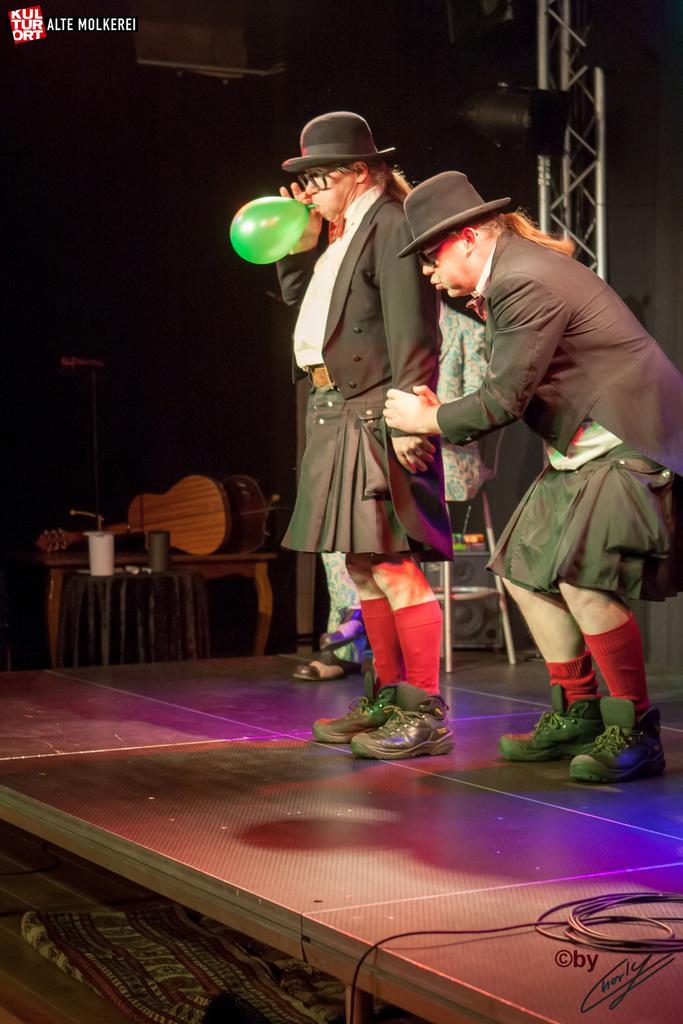How would you summarize this image in a sentence or two? In this image there are three persons standing on the stage and under the stage there is a mat. Beside the stage there are two tables where on one table two objects were placed and on another table two guitars are placed. Beside the table there is a mike and at the background there is a speaker. 